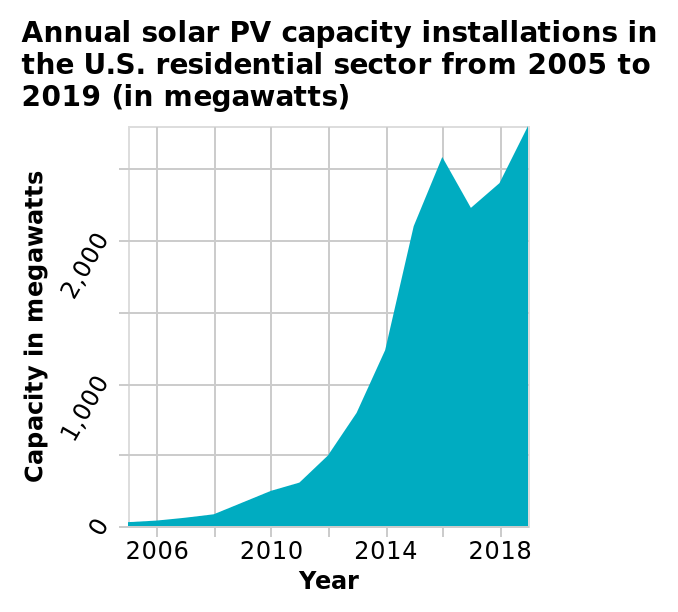<image>
What is the range of years covered in the chart? The chart covers the years from 2005 to 2019. please describe the details of the chart Annual solar PV capacity installations in the U.S. residential sector from 2005 to 2019 (in megawatts) is a area chart. The y-axis plots Capacity in megawatts while the x-axis shows Year. 